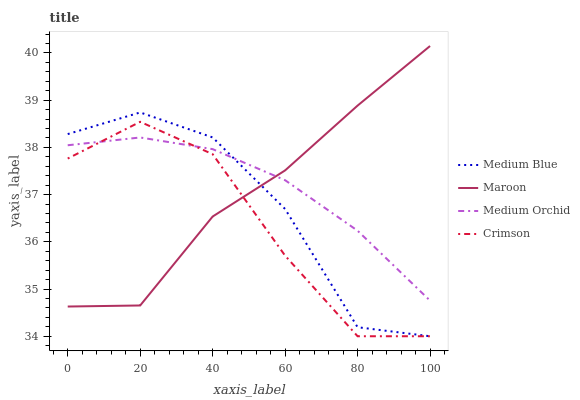Does Medium Blue have the minimum area under the curve?
Answer yes or no. No. Does Medium Blue have the maximum area under the curve?
Answer yes or no. No. Is Medium Blue the smoothest?
Answer yes or no. No. Is Medium Orchid the roughest?
Answer yes or no. No. Does Medium Orchid have the lowest value?
Answer yes or no. No. Does Medium Blue have the highest value?
Answer yes or no. No. 